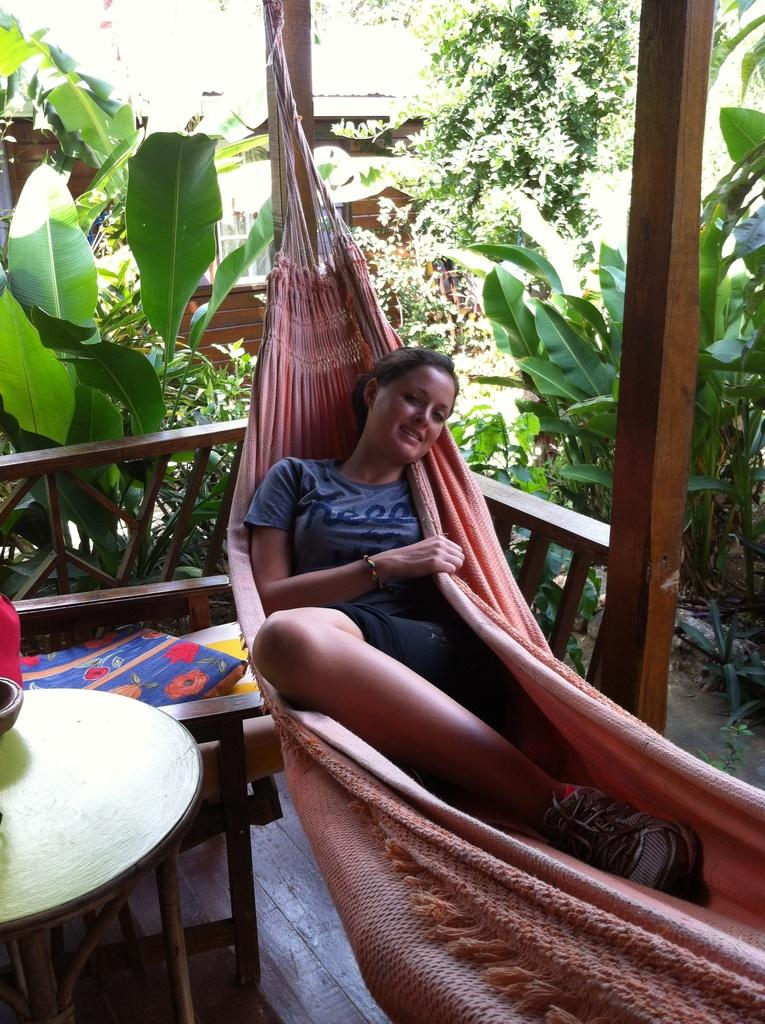Who is present in the image? There is a woman in the image. What is the woman doing in the image? The woman is sleeping in a cradle. How is the cradle positioned in the image? The cradle is hanged from the pillars of the house. What furniture is present near the cradle? There is a table and a chair beside the cradle. What can be seen in the background of the image? There are trees visible in the background of the image. What type of brick is used to construct the house in the image? There is no information about the construction of the house in the image, so it is not possible to determine the type of brick used. How many breaths does the woman take per minute in the image? It is not possible to determine the woman's breathing rate from the image. 